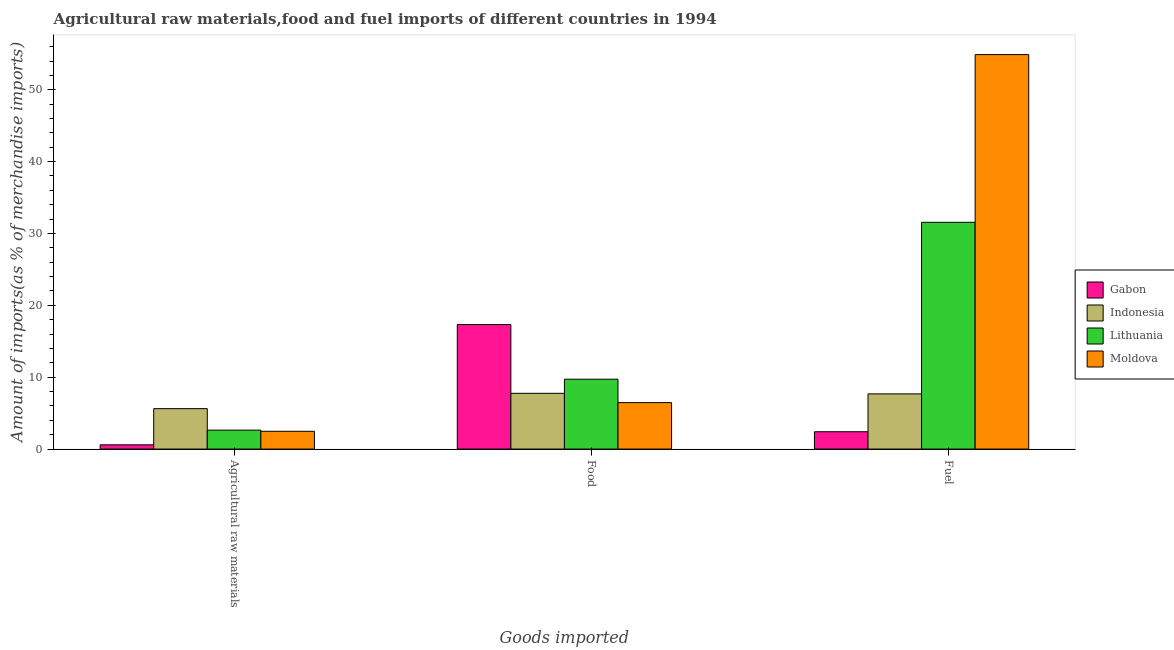How many different coloured bars are there?
Give a very brief answer. 4. How many bars are there on the 3rd tick from the left?
Your response must be concise. 4. What is the label of the 2nd group of bars from the left?
Your response must be concise. Food. What is the percentage of food imports in Gabon?
Ensure brevity in your answer.  17.33. Across all countries, what is the maximum percentage of raw materials imports?
Keep it short and to the point. 5.63. Across all countries, what is the minimum percentage of raw materials imports?
Ensure brevity in your answer.  0.59. In which country was the percentage of fuel imports maximum?
Provide a short and direct response. Moldova. In which country was the percentage of fuel imports minimum?
Your response must be concise. Gabon. What is the total percentage of fuel imports in the graph?
Offer a very short reply. 96.54. What is the difference between the percentage of food imports in Gabon and that in Moldova?
Provide a short and direct response. 10.86. What is the difference between the percentage of fuel imports in Lithuania and the percentage of food imports in Indonesia?
Your answer should be compact. 23.8. What is the average percentage of raw materials imports per country?
Keep it short and to the point. 2.83. What is the difference between the percentage of food imports and percentage of raw materials imports in Lithuania?
Make the answer very short. 7.09. In how many countries, is the percentage of fuel imports greater than 30 %?
Keep it short and to the point. 2. What is the ratio of the percentage of fuel imports in Indonesia to that in Lithuania?
Provide a succinct answer. 0.24. Is the difference between the percentage of fuel imports in Moldova and Gabon greater than the difference between the percentage of food imports in Moldova and Gabon?
Offer a terse response. Yes. What is the difference between the highest and the second highest percentage of raw materials imports?
Ensure brevity in your answer.  2.99. What is the difference between the highest and the lowest percentage of raw materials imports?
Ensure brevity in your answer.  5.03. What does the 2nd bar from the left in Agricultural raw materials represents?
Offer a terse response. Indonesia. What does the 4th bar from the right in Food represents?
Make the answer very short. Gabon. Is it the case that in every country, the sum of the percentage of raw materials imports and percentage of food imports is greater than the percentage of fuel imports?
Make the answer very short. No. Are all the bars in the graph horizontal?
Make the answer very short. No. Are the values on the major ticks of Y-axis written in scientific E-notation?
Offer a very short reply. No. How are the legend labels stacked?
Keep it short and to the point. Vertical. What is the title of the graph?
Ensure brevity in your answer.  Agricultural raw materials,food and fuel imports of different countries in 1994. What is the label or title of the X-axis?
Offer a terse response. Goods imported. What is the label or title of the Y-axis?
Offer a very short reply. Amount of imports(as % of merchandise imports). What is the Amount of imports(as % of merchandise imports) in Gabon in Agricultural raw materials?
Your answer should be compact. 0.59. What is the Amount of imports(as % of merchandise imports) in Indonesia in Agricultural raw materials?
Your answer should be compact. 5.63. What is the Amount of imports(as % of merchandise imports) in Lithuania in Agricultural raw materials?
Offer a terse response. 2.64. What is the Amount of imports(as % of merchandise imports) in Moldova in Agricultural raw materials?
Your answer should be very brief. 2.48. What is the Amount of imports(as % of merchandise imports) in Gabon in Food?
Keep it short and to the point. 17.33. What is the Amount of imports(as % of merchandise imports) of Indonesia in Food?
Give a very brief answer. 7.76. What is the Amount of imports(as % of merchandise imports) of Lithuania in Food?
Ensure brevity in your answer.  9.72. What is the Amount of imports(as % of merchandise imports) of Moldova in Food?
Give a very brief answer. 6.46. What is the Amount of imports(as % of merchandise imports) of Gabon in Fuel?
Provide a short and direct response. 2.41. What is the Amount of imports(as % of merchandise imports) of Indonesia in Fuel?
Ensure brevity in your answer.  7.68. What is the Amount of imports(as % of merchandise imports) of Lithuania in Fuel?
Keep it short and to the point. 31.56. What is the Amount of imports(as % of merchandise imports) in Moldova in Fuel?
Keep it short and to the point. 54.89. Across all Goods imported, what is the maximum Amount of imports(as % of merchandise imports) in Gabon?
Give a very brief answer. 17.33. Across all Goods imported, what is the maximum Amount of imports(as % of merchandise imports) of Indonesia?
Keep it short and to the point. 7.76. Across all Goods imported, what is the maximum Amount of imports(as % of merchandise imports) in Lithuania?
Provide a short and direct response. 31.56. Across all Goods imported, what is the maximum Amount of imports(as % of merchandise imports) of Moldova?
Ensure brevity in your answer.  54.89. Across all Goods imported, what is the minimum Amount of imports(as % of merchandise imports) in Gabon?
Offer a very short reply. 0.59. Across all Goods imported, what is the minimum Amount of imports(as % of merchandise imports) of Indonesia?
Make the answer very short. 5.63. Across all Goods imported, what is the minimum Amount of imports(as % of merchandise imports) of Lithuania?
Give a very brief answer. 2.64. Across all Goods imported, what is the minimum Amount of imports(as % of merchandise imports) in Moldova?
Provide a short and direct response. 2.48. What is the total Amount of imports(as % of merchandise imports) of Gabon in the graph?
Offer a very short reply. 20.33. What is the total Amount of imports(as % of merchandise imports) of Indonesia in the graph?
Your answer should be compact. 21.06. What is the total Amount of imports(as % of merchandise imports) of Lithuania in the graph?
Your answer should be very brief. 43.92. What is the total Amount of imports(as % of merchandise imports) in Moldova in the graph?
Your answer should be compact. 63.83. What is the difference between the Amount of imports(as % of merchandise imports) of Gabon in Agricultural raw materials and that in Food?
Your response must be concise. -16.73. What is the difference between the Amount of imports(as % of merchandise imports) of Indonesia in Agricultural raw materials and that in Food?
Ensure brevity in your answer.  -2.13. What is the difference between the Amount of imports(as % of merchandise imports) in Lithuania in Agricultural raw materials and that in Food?
Offer a terse response. -7.09. What is the difference between the Amount of imports(as % of merchandise imports) in Moldova in Agricultural raw materials and that in Food?
Your response must be concise. -3.99. What is the difference between the Amount of imports(as % of merchandise imports) of Gabon in Agricultural raw materials and that in Fuel?
Keep it short and to the point. -1.82. What is the difference between the Amount of imports(as % of merchandise imports) of Indonesia in Agricultural raw materials and that in Fuel?
Your response must be concise. -2.05. What is the difference between the Amount of imports(as % of merchandise imports) of Lithuania in Agricultural raw materials and that in Fuel?
Provide a short and direct response. -28.92. What is the difference between the Amount of imports(as % of merchandise imports) of Moldova in Agricultural raw materials and that in Fuel?
Keep it short and to the point. -52.42. What is the difference between the Amount of imports(as % of merchandise imports) of Gabon in Food and that in Fuel?
Keep it short and to the point. 14.91. What is the difference between the Amount of imports(as % of merchandise imports) in Indonesia in Food and that in Fuel?
Give a very brief answer. 0.08. What is the difference between the Amount of imports(as % of merchandise imports) in Lithuania in Food and that in Fuel?
Offer a very short reply. -21.83. What is the difference between the Amount of imports(as % of merchandise imports) in Moldova in Food and that in Fuel?
Offer a terse response. -48.43. What is the difference between the Amount of imports(as % of merchandise imports) of Gabon in Agricultural raw materials and the Amount of imports(as % of merchandise imports) of Indonesia in Food?
Provide a short and direct response. -7.17. What is the difference between the Amount of imports(as % of merchandise imports) in Gabon in Agricultural raw materials and the Amount of imports(as % of merchandise imports) in Lithuania in Food?
Your answer should be very brief. -9.13. What is the difference between the Amount of imports(as % of merchandise imports) of Gabon in Agricultural raw materials and the Amount of imports(as % of merchandise imports) of Moldova in Food?
Keep it short and to the point. -5.87. What is the difference between the Amount of imports(as % of merchandise imports) in Indonesia in Agricultural raw materials and the Amount of imports(as % of merchandise imports) in Lithuania in Food?
Make the answer very short. -4.1. What is the difference between the Amount of imports(as % of merchandise imports) in Indonesia in Agricultural raw materials and the Amount of imports(as % of merchandise imports) in Moldova in Food?
Provide a short and direct response. -0.84. What is the difference between the Amount of imports(as % of merchandise imports) of Lithuania in Agricultural raw materials and the Amount of imports(as % of merchandise imports) of Moldova in Food?
Provide a short and direct response. -3.83. What is the difference between the Amount of imports(as % of merchandise imports) of Gabon in Agricultural raw materials and the Amount of imports(as % of merchandise imports) of Indonesia in Fuel?
Ensure brevity in your answer.  -7.09. What is the difference between the Amount of imports(as % of merchandise imports) in Gabon in Agricultural raw materials and the Amount of imports(as % of merchandise imports) in Lithuania in Fuel?
Give a very brief answer. -30.96. What is the difference between the Amount of imports(as % of merchandise imports) of Gabon in Agricultural raw materials and the Amount of imports(as % of merchandise imports) of Moldova in Fuel?
Keep it short and to the point. -54.3. What is the difference between the Amount of imports(as % of merchandise imports) in Indonesia in Agricultural raw materials and the Amount of imports(as % of merchandise imports) in Lithuania in Fuel?
Give a very brief answer. -25.93. What is the difference between the Amount of imports(as % of merchandise imports) of Indonesia in Agricultural raw materials and the Amount of imports(as % of merchandise imports) of Moldova in Fuel?
Offer a very short reply. -49.27. What is the difference between the Amount of imports(as % of merchandise imports) of Lithuania in Agricultural raw materials and the Amount of imports(as % of merchandise imports) of Moldova in Fuel?
Keep it short and to the point. -52.26. What is the difference between the Amount of imports(as % of merchandise imports) in Gabon in Food and the Amount of imports(as % of merchandise imports) in Indonesia in Fuel?
Keep it short and to the point. 9.65. What is the difference between the Amount of imports(as % of merchandise imports) in Gabon in Food and the Amount of imports(as % of merchandise imports) in Lithuania in Fuel?
Give a very brief answer. -14.23. What is the difference between the Amount of imports(as % of merchandise imports) of Gabon in Food and the Amount of imports(as % of merchandise imports) of Moldova in Fuel?
Provide a short and direct response. -37.56. What is the difference between the Amount of imports(as % of merchandise imports) in Indonesia in Food and the Amount of imports(as % of merchandise imports) in Lithuania in Fuel?
Offer a terse response. -23.8. What is the difference between the Amount of imports(as % of merchandise imports) of Indonesia in Food and the Amount of imports(as % of merchandise imports) of Moldova in Fuel?
Your answer should be compact. -47.13. What is the difference between the Amount of imports(as % of merchandise imports) in Lithuania in Food and the Amount of imports(as % of merchandise imports) in Moldova in Fuel?
Your answer should be compact. -45.17. What is the average Amount of imports(as % of merchandise imports) of Gabon per Goods imported?
Your response must be concise. 6.78. What is the average Amount of imports(as % of merchandise imports) of Indonesia per Goods imported?
Provide a short and direct response. 7.02. What is the average Amount of imports(as % of merchandise imports) of Lithuania per Goods imported?
Offer a very short reply. 14.64. What is the average Amount of imports(as % of merchandise imports) of Moldova per Goods imported?
Give a very brief answer. 21.28. What is the difference between the Amount of imports(as % of merchandise imports) in Gabon and Amount of imports(as % of merchandise imports) in Indonesia in Agricultural raw materials?
Provide a short and direct response. -5.03. What is the difference between the Amount of imports(as % of merchandise imports) in Gabon and Amount of imports(as % of merchandise imports) in Lithuania in Agricultural raw materials?
Make the answer very short. -2.04. What is the difference between the Amount of imports(as % of merchandise imports) in Gabon and Amount of imports(as % of merchandise imports) in Moldova in Agricultural raw materials?
Offer a terse response. -1.88. What is the difference between the Amount of imports(as % of merchandise imports) of Indonesia and Amount of imports(as % of merchandise imports) of Lithuania in Agricultural raw materials?
Make the answer very short. 2.99. What is the difference between the Amount of imports(as % of merchandise imports) in Indonesia and Amount of imports(as % of merchandise imports) in Moldova in Agricultural raw materials?
Your answer should be compact. 3.15. What is the difference between the Amount of imports(as % of merchandise imports) of Lithuania and Amount of imports(as % of merchandise imports) of Moldova in Agricultural raw materials?
Make the answer very short. 0.16. What is the difference between the Amount of imports(as % of merchandise imports) of Gabon and Amount of imports(as % of merchandise imports) of Indonesia in Food?
Your answer should be very brief. 9.57. What is the difference between the Amount of imports(as % of merchandise imports) in Gabon and Amount of imports(as % of merchandise imports) in Lithuania in Food?
Your response must be concise. 7.6. What is the difference between the Amount of imports(as % of merchandise imports) in Gabon and Amount of imports(as % of merchandise imports) in Moldova in Food?
Provide a short and direct response. 10.86. What is the difference between the Amount of imports(as % of merchandise imports) in Indonesia and Amount of imports(as % of merchandise imports) in Lithuania in Food?
Provide a succinct answer. -1.97. What is the difference between the Amount of imports(as % of merchandise imports) of Indonesia and Amount of imports(as % of merchandise imports) of Moldova in Food?
Provide a succinct answer. 1.29. What is the difference between the Amount of imports(as % of merchandise imports) of Lithuania and Amount of imports(as % of merchandise imports) of Moldova in Food?
Give a very brief answer. 3.26. What is the difference between the Amount of imports(as % of merchandise imports) in Gabon and Amount of imports(as % of merchandise imports) in Indonesia in Fuel?
Give a very brief answer. -5.27. What is the difference between the Amount of imports(as % of merchandise imports) in Gabon and Amount of imports(as % of merchandise imports) in Lithuania in Fuel?
Ensure brevity in your answer.  -29.14. What is the difference between the Amount of imports(as % of merchandise imports) of Gabon and Amount of imports(as % of merchandise imports) of Moldova in Fuel?
Your response must be concise. -52.48. What is the difference between the Amount of imports(as % of merchandise imports) in Indonesia and Amount of imports(as % of merchandise imports) in Lithuania in Fuel?
Offer a terse response. -23.88. What is the difference between the Amount of imports(as % of merchandise imports) in Indonesia and Amount of imports(as % of merchandise imports) in Moldova in Fuel?
Provide a succinct answer. -47.21. What is the difference between the Amount of imports(as % of merchandise imports) of Lithuania and Amount of imports(as % of merchandise imports) of Moldova in Fuel?
Keep it short and to the point. -23.34. What is the ratio of the Amount of imports(as % of merchandise imports) of Gabon in Agricultural raw materials to that in Food?
Provide a succinct answer. 0.03. What is the ratio of the Amount of imports(as % of merchandise imports) in Indonesia in Agricultural raw materials to that in Food?
Offer a very short reply. 0.73. What is the ratio of the Amount of imports(as % of merchandise imports) of Lithuania in Agricultural raw materials to that in Food?
Your answer should be very brief. 0.27. What is the ratio of the Amount of imports(as % of merchandise imports) of Moldova in Agricultural raw materials to that in Food?
Your answer should be very brief. 0.38. What is the ratio of the Amount of imports(as % of merchandise imports) in Gabon in Agricultural raw materials to that in Fuel?
Your response must be concise. 0.25. What is the ratio of the Amount of imports(as % of merchandise imports) in Indonesia in Agricultural raw materials to that in Fuel?
Your response must be concise. 0.73. What is the ratio of the Amount of imports(as % of merchandise imports) of Lithuania in Agricultural raw materials to that in Fuel?
Make the answer very short. 0.08. What is the ratio of the Amount of imports(as % of merchandise imports) in Moldova in Agricultural raw materials to that in Fuel?
Provide a succinct answer. 0.05. What is the ratio of the Amount of imports(as % of merchandise imports) of Gabon in Food to that in Fuel?
Keep it short and to the point. 7.18. What is the ratio of the Amount of imports(as % of merchandise imports) in Indonesia in Food to that in Fuel?
Provide a short and direct response. 1.01. What is the ratio of the Amount of imports(as % of merchandise imports) in Lithuania in Food to that in Fuel?
Your answer should be very brief. 0.31. What is the ratio of the Amount of imports(as % of merchandise imports) of Moldova in Food to that in Fuel?
Provide a succinct answer. 0.12. What is the difference between the highest and the second highest Amount of imports(as % of merchandise imports) in Gabon?
Your response must be concise. 14.91. What is the difference between the highest and the second highest Amount of imports(as % of merchandise imports) in Indonesia?
Ensure brevity in your answer.  0.08. What is the difference between the highest and the second highest Amount of imports(as % of merchandise imports) in Lithuania?
Keep it short and to the point. 21.83. What is the difference between the highest and the second highest Amount of imports(as % of merchandise imports) of Moldova?
Keep it short and to the point. 48.43. What is the difference between the highest and the lowest Amount of imports(as % of merchandise imports) in Gabon?
Offer a terse response. 16.73. What is the difference between the highest and the lowest Amount of imports(as % of merchandise imports) of Indonesia?
Offer a very short reply. 2.13. What is the difference between the highest and the lowest Amount of imports(as % of merchandise imports) of Lithuania?
Your response must be concise. 28.92. What is the difference between the highest and the lowest Amount of imports(as % of merchandise imports) in Moldova?
Your response must be concise. 52.42. 